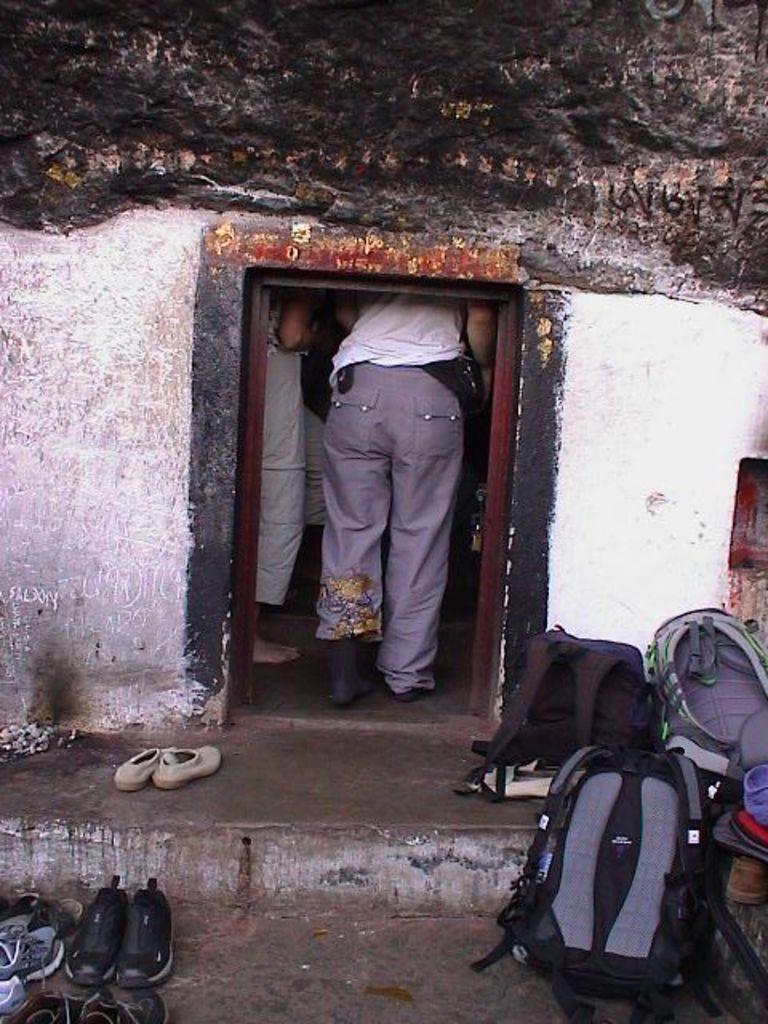In one or two sentences, can you explain what this image depicts? In this picture we can see a house. Inside the house we can see two persons standing. Here we can see backpacks , footwear near to the house. 